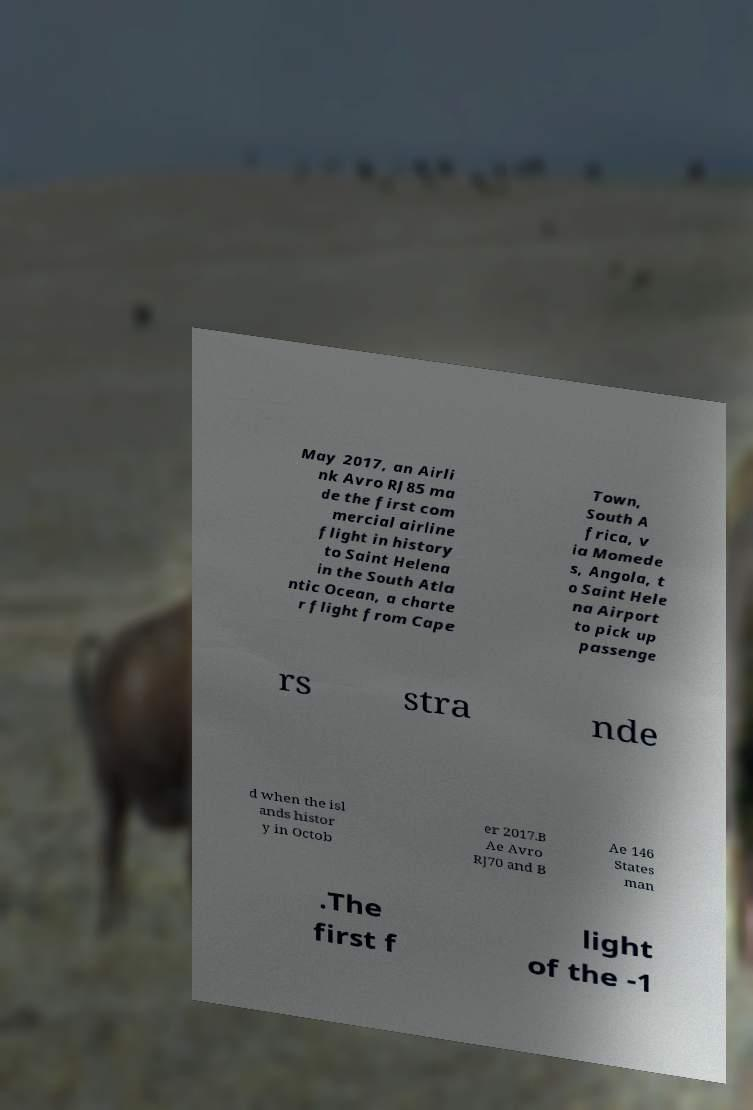Can you read and provide the text displayed in the image?This photo seems to have some interesting text. Can you extract and type it out for me? May 2017, an Airli nk Avro RJ85 ma de the first com mercial airline flight in history to Saint Helena in the South Atla ntic Ocean, a charte r flight from Cape Town, South A frica, v ia Momede s, Angola, t o Saint Hele na Airport to pick up passenge rs stra nde d when the isl ands histor y in Octob er 2017.B Ae Avro RJ70 and B Ae 146 States man .The first f light of the -1 